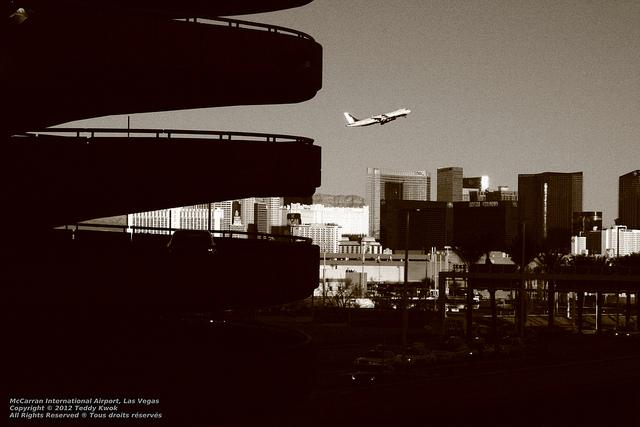What is taking off? airplane 